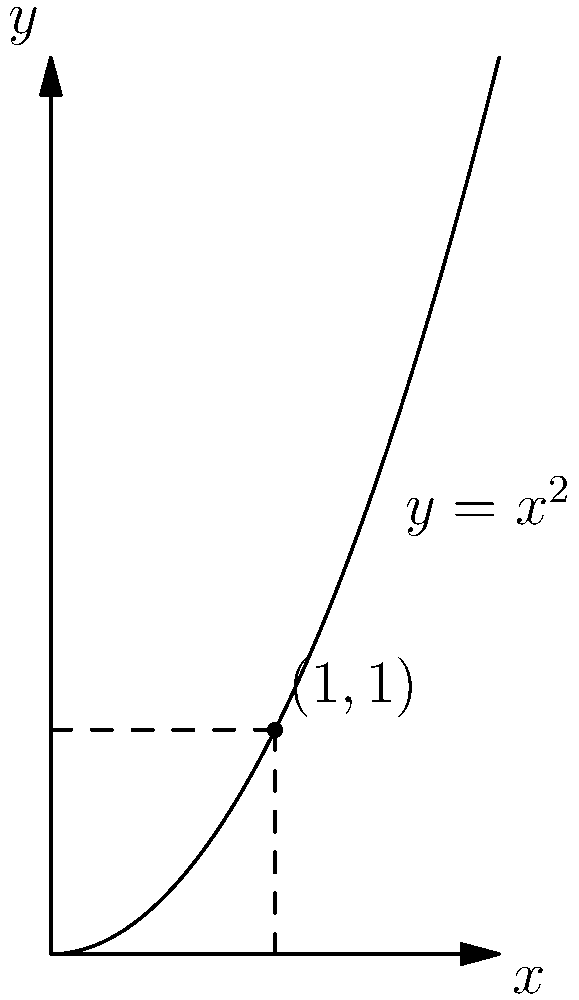A particle is moving along the curve $y=x^2$. At the point $(1,1)$, what is the instantaneous rate of change of the particle's vertical position with respect to its horizontal position? To find the instantaneous rate of change of the particle's vertical position with respect to its horizontal position, we need to calculate the derivative of the function $y=x^2$ at the point $(1,1)$.

Step 1: Find the general derivative of $y=x^2$.
The derivative of $y=x^2$ is $\frac{dy}{dx} = 2x$.

Step 2: Evaluate the derivative at the point $(1,1)$.
At $x=1$, we have:
$\frac{dy}{dx}|_{x=1} = 2(1) = 2$

Step 3: Interpret the result.
The value 2 represents the slope of the tangent line to the curve at the point $(1,1)$. This slope gives us the instantaneous rate of change of the particle's vertical position with respect to its horizontal position.

Therefore, at the point $(1,1)$, the particle's vertical position is changing at a rate of 2 units for every 1 unit of horizontal change.
Answer: 2 